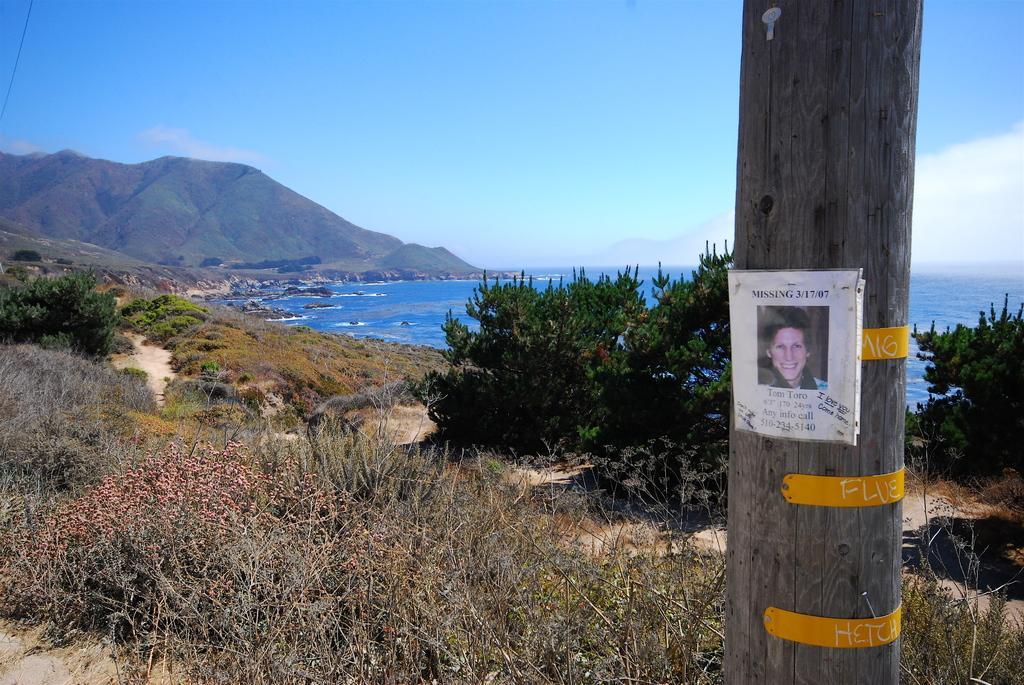Could you give a brief overview of what you see in this image? To the right side of the image there is a wooden pole with a poster on it. And to the bottom of the image there is a grass on the ground. And also there are few plants and trees. In the background there is a water and also the left corner there is a hill. And to the top of the image there is a sky. 